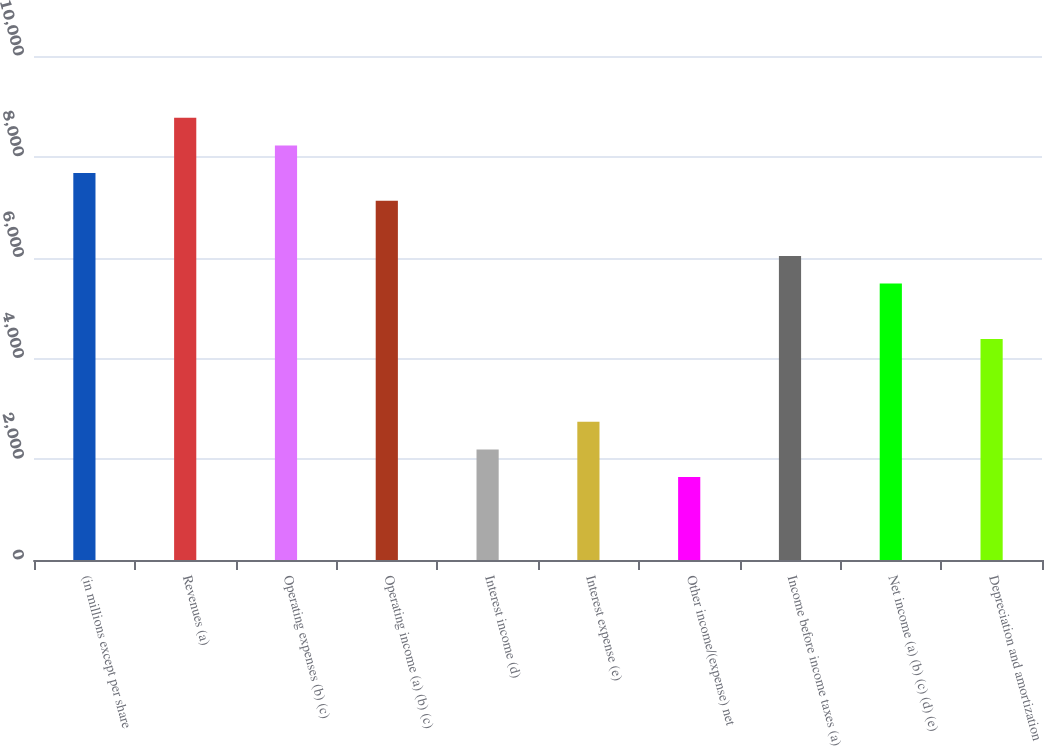Convert chart to OTSL. <chart><loc_0><loc_0><loc_500><loc_500><bar_chart><fcel>(in millions except per share<fcel>Revenues (a)<fcel>Operating expenses (b) (c)<fcel>Operating income (a) (b) (c)<fcel>Interest income (d)<fcel>Interest expense (e)<fcel>Other income/(expense) net<fcel>Income before income taxes (a)<fcel>Net income (a) (b) (c) (d) (e)<fcel>Depreciation and amortization<nl><fcel>7676.96<fcel>8773.58<fcel>8225.27<fcel>7128.65<fcel>2193.86<fcel>2742.17<fcel>1645.55<fcel>6032.03<fcel>5483.72<fcel>4387.1<nl></chart> 